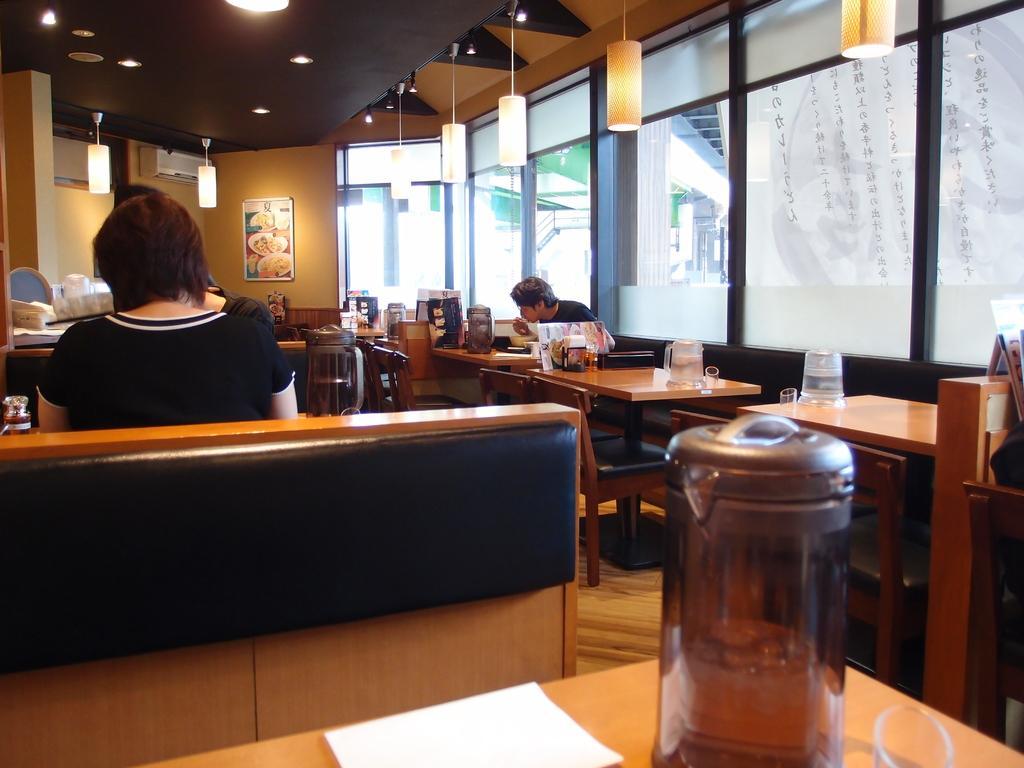Describe this image in one or two sentences. In this image I see lot of chairs and tables and on the tables I see few things, I can also see few people. In the background I see the windows, lights, wall and the ceiling. 